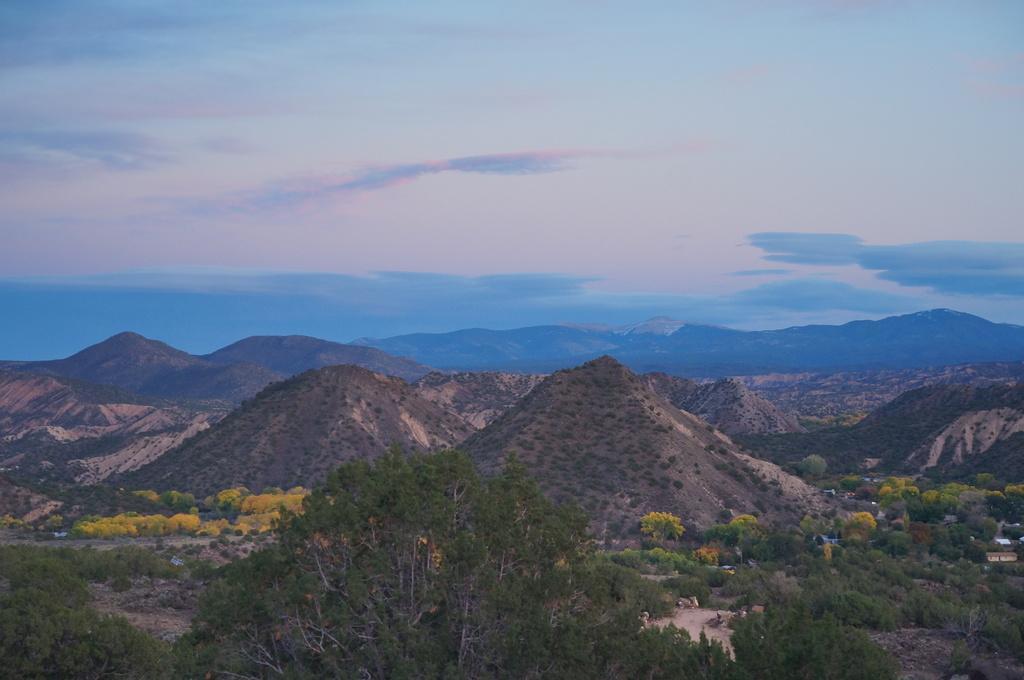Can you describe this image briefly? In the image we can see hills, trees and the cloudy pale blue and pale purple sky. 